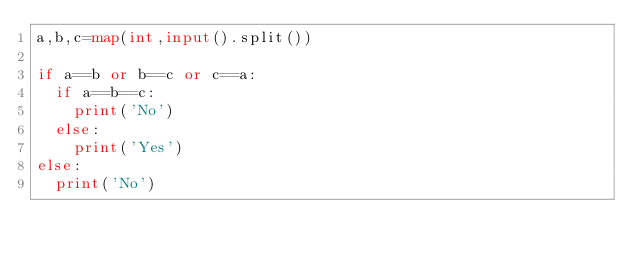Convert code to text. <code><loc_0><loc_0><loc_500><loc_500><_Python_>a,b,c=map(int,input().split())

if a==b or b==c or c==a:
  if a==b==c:
    print('No')
  else:
    print('Yes')
else:
  print('No')</code> 